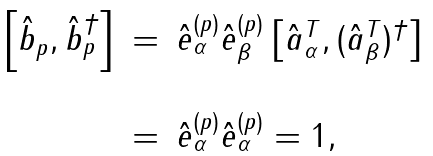Convert formula to latex. <formula><loc_0><loc_0><loc_500><loc_500>\begin{array} { l c l } \left [ \hat { b } _ { p } , \hat { b } _ { p } ^ { \dagger } \right ] & = & \hat { e } _ { \alpha } ^ { ( p ) } \hat { e } _ { \beta } ^ { ( p ) } \left [ \hat { a } ^ { T } _ { \alpha } , ( \hat { a } ^ { T } _ { \beta } ) ^ { \dagger } \right ] \\ \\ & = & \hat { e } _ { \alpha } ^ { ( p ) } \hat { e } _ { \alpha } ^ { ( p ) } = 1 , \\ \end{array}</formula> 